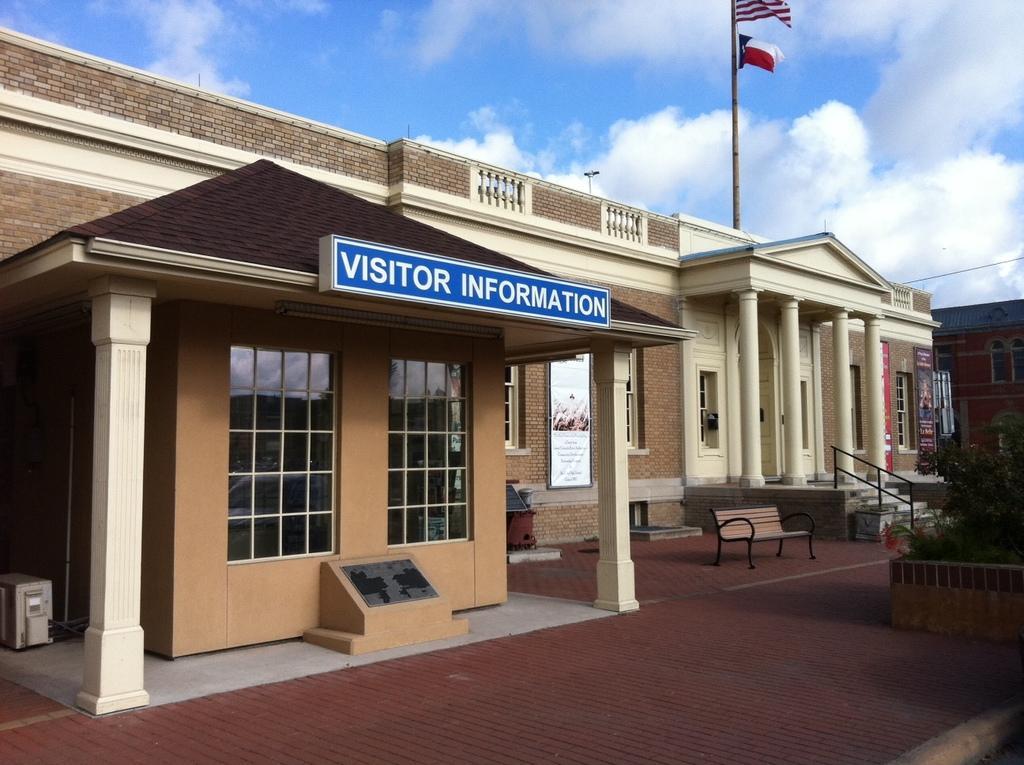How would you summarize this image in a sentence or two? There are architectures, a board, planter, bench and flags in the foreground area of the image and the sky in the background. 